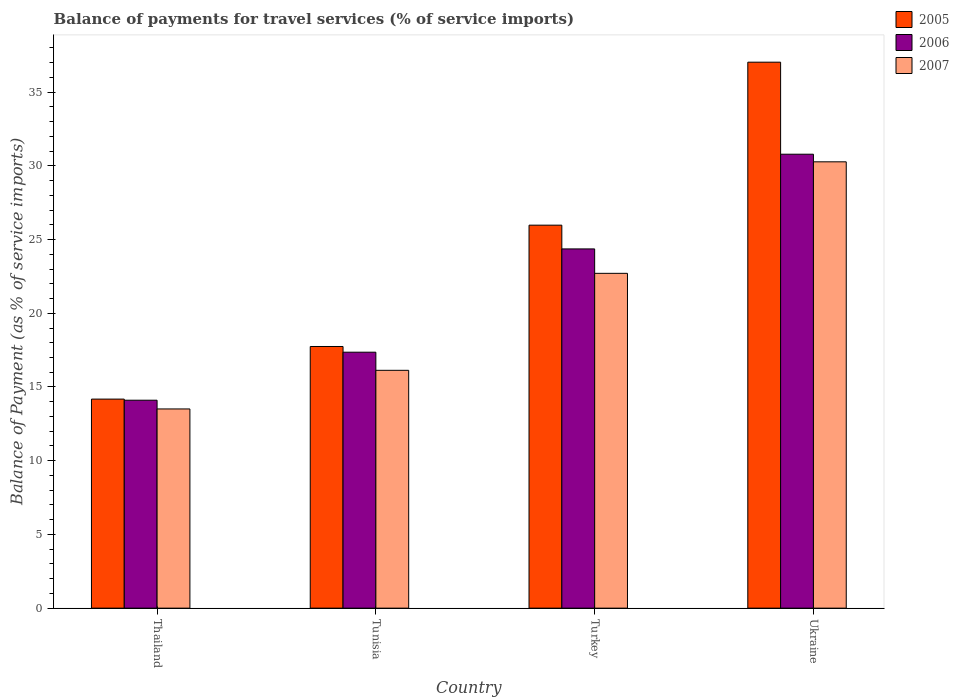How many different coloured bars are there?
Offer a very short reply. 3. Are the number of bars per tick equal to the number of legend labels?
Your answer should be very brief. Yes. Are the number of bars on each tick of the X-axis equal?
Give a very brief answer. Yes. How many bars are there on the 1st tick from the left?
Make the answer very short. 3. What is the label of the 2nd group of bars from the left?
Offer a terse response. Tunisia. In how many cases, is the number of bars for a given country not equal to the number of legend labels?
Your answer should be very brief. 0. What is the balance of payments for travel services in 2006 in Tunisia?
Provide a short and direct response. 17.36. Across all countries, what is the maximum balance of payments for travel services in 2006?
Your answer should be compact. 30.79. Across all countries, what is the minimum balance of payments for travel services in 2007?
Provide a succinct answer. 13.51. In which country was the balance of payments for travel services in 2005 maximum?
Offer a terse response. Ukraine. In which country was the balance of payments for travel services in 2005 minimum?
Offer a terse response. Thailand. What is the total balance of payments for travel services in 2006 in the graph?
Keep it short and to the point. 86.61. What is the difference between the balance of payments for travel services in 2007 in Tunisia and that in Ukraine?
Provide a succinct answer. -14.14. What is the difference between the balance of payments for travel services in 2007 in Ukraine and the balance of payments for travel services in 2006 in Tunisia?
Your answer should be compact. 12.91. What is the average balance of payments for travel services in 2007 per country?
Make the answer very short. 20.65. What is the difference between the balance of payments for travel services of/in 2005 and balance of payments for travel services of/in 2007 in Thailand?
Give a very brief answer. 0.67. What is the ratio of the balance of payments for travel services in 2007 in Thailand to that in Ukraine?
Your answer should be compact. 0.45. Is the balance of payments for travel services in 2007 in Thailand less than that in Tunisia?
Keep it short and to the point. Yes. Is the difference between the balance of payments for travel services in 2005 in Tunisia and Ukraine greater than the difference between the balance of payments for travel services in 2007 in Tunisia and Ukraine?
Offer a terse response. No. What is the difference between the highest and the second highest balance of payments for travel services in 2006?
Your answer should be very brief. 7.01. What is the difference between the highest and the lowest balance of payments for travel services in 2007?
Offer a very short reply. 16.76. Is the sum of the balance of payments for travel services in 2005 in Tunisia and Ukraine greater than the maximum balance of payments for travel services in 2006 across all countries?
Make the answer very short. Yes. What does the 1st bar from the right in Turkey represents?
Offer a terse response. 2007. Is it the case that in every country, the sum of the balance of payments for travel services in 2005 and balance of payments for travel services in 2007 is greater than the balance of payments for travel services in 2006?
Your answer should be very brief. Yes. Does the graph contain any zero values?
Your answer should be compact. No. Does the graph contain grids?
Provide a succinct answer. No. How many legend labels are there?
Provide a short and direct response. 3. What is the title of the graph?
Offer a very short reply. Balance of payments for travel services (% of service imports). Does "1983" appear as one of the legend labels in the graph?
Ensure brevity in your answer.  No. What is the label or title of the X-axis?
Provide a succinct answer. Country. What is the label or title of the Y-axis?
Make the answer very short. Balance of Payment (as % of service imports). What is the Balance of Payment (as % of service imports) in 2005 in Thailand?
Your response must be concise. 14.18. What is the Balance of Payment (as % of service imports) in 2006 in Thailand?
Give a very brief answer. 14.1. What is the Balance of Payment (as % of service imports) in 2007 in Thailand?
Offer a very short reply. 13.51. What is the Balance of Payment (as % of service imports) in 2005 in Tunisia?
Provide a short and direct response. 17.75. What is the Balance of Payment (as % of service imports) in 2006 in Tunisia?
Your response must be concise. 17.36. What is the Balance of Payment (as % of service imports) of 2007 in Tunisia?
Your answer should be compact. 16.13. What is the Balance of Payment (as % of service imports) in 2005 in Turkey?
Make the answer very short. 25.97. What is the Balance of Payment (as % of service imports) in 2006 in Turkey?
Your answer should be very brief. 24.36. What is the Balance of Payment (as % of service imports) in 2007 in Turkey?
Your answer should be compact. 22.71. What is the Balance of Payment (as % of service imports) of 2005 in Ukraine?
Your answer should be very brief. 37.03. What is the Balance of Payment (as % of service imports) of 2006 in Ukraine?
Keep it short and to the point. 30.79. What is the Balance of Payment (as % of service imports) in 2007 in Ukraine?
Your answer should be very brief. 30.27. Across all countries, what is the maximum Balance of Payment (as % of service imports) in 2005?
Provide a short and direct response. 37.03. Across all countries, what is the maximum Balance of Payment (as % of service imports) of 2006?
Keep it short and to the point. 30.79. Across all countries, what is the maximum Balance of Payment (as % of service imports) in 2007?
Keep it short and to the point. 30.27. Across all countries, what is the minimum Balance of Payment (as % of service imports) of 2005?
Ensure brevity in your answer.  14.18. Across all countries, what is the minimum Balance of Payment (as % of service imports) in 2006?
Ensure brevity in your answer.  14.1. Across all countries, what is the minimum Balance of Payment (as % of service imports) of 2007?
Your answer should be compact. 13.51. What is the total Balance of Payment (as % of service imports) of 2005 in the graph?
Keep it short and to the point. 94.93. What is the total Balance of Payment (as % of service imports) in 2006 in the graph?
Your response must be concise. 86.61. What is the total Balance of Payment (as % of service imports) in 2007 in the graph?
Keep it short and to the point. 82.62. What is the difference between the Balance of Payment (as % of service imports) in 2005 in Thailand and that in Tunisia?
Keep it short and to the point. -3.57. What is the difference between the Balance of Payment (as % of service imports) in 2006 in Thailand and that in Tunisia?
Your answer should be compact. -3.26. What is the difference between the Balance of Payment (as % of service imports) of 2007 in Thailand and that in Tunisia?
Your answer should be compact. -2.62. What is the difference between the Balance of Payment (as % of service imports) in 2005 in Thailand and that in Turkey?
Your answer should be very brief. -11.8. What is the difference between the Balance of Payment (as % of service imports) in 2006 in Thailand and that in Turkey?
Provide a succinct answer. -10.26. What is the difference between the Balance of Payment (as % of service imports) of 2007 in Thailand and that in Turkey?
Keep it short and to the point. -9.2. What is the difference between the Balance of Payment (as % of service imports) in 2005 in Thailand and that in Ukraine?
Provide a succinct answer. -22.85. What is the difference between the Balance of Payment (as % of service imports) in 2006 in Thailand and that in Ukraine?
Make the answer very short. -16.68. What is the difference between the Balance of Payment (as % of service imports) of 2007 in Thailand and that in Ukraine?
Keep it short and to the point. -16.76. What is the difference between the Balance of Payment (as % of service imports) of 2005 in Tunisia and that in Turkey?
Your answer should be compact. -8.23. What is the difference between the Balance of Payment (as % of service imports) in 2006 in Tunisia and that in Turkey?
Provide a succinct answer. -7.01. What is the difference between the Balance of Payment (as % of service imports) in 2007 in Tunisia and that in Turkey?
Provide a short and direct response. -6.58. What is the difference between the Balance of Payment (as % of service imports) of 2005 in Tunisia and that in Ukraine?
Ensure brevity in your answer.  -19.28. What is the difference between the Balance of Payment (as % of service imports) in 2006 in Tunisia and that in Ukraine?
Give a very brief answer. -13.43. What is the difference between the Balance of Payment (as % of service imports) of 2007 in Tunisia and that in Ukraine?
Ensure brevity in your answer.  -14.14. What is the difference between the Balance of Payment (as % of service imports) of 2005 in Turkey and that in Ukraine?
Make the answer very short. -11.05. What is the difference between the Balance of Payment (as % of service imports) of 2006 in Turkey and that in Ukraine?
Keep it short and to the point. -6.42. What is the difference between the Balance of Payment (as % of service imports) of 2007 in Turkey and that in Ukraine?
Your answer should be very brief. -7.56. What is the difference between the Balance of Payment (as % of service imports) in 2005 in Thailand and the Balance of Payment (as % of service imports) in 2006 in Tunisia?
Offer a terse response. -3.18. What is the difference between the Balance of Payment (as % of service imports) of 2005 in Thailand and the Balance of Payment (as % of service imports) of 2007 in Tunisia?
Your answer should be very brief. -1.95. What is the difference between the Balance of Payment (as % of service imports) in 2006 in Thailand and the Balance of Payment (as % of service imports) in 2007 in Tunisia?
Ensure brevity in your answer.  -2.03. What is the difference between the Balance of Payment (as % of service imports) of 2005 in Thailand and the Balance of Payment (as % of service imports) of 2006 in Turkey?
Give a very brief answer. -10.19. What is the difference between the Balance of Payment (as % of service imports) of 2005 in Thailand and the Balance of Payment (as % of service imports) of 2007 in Turkey?
Ensure brevity in your answer.  -8.53. What is the difference between the Balance of Payment (as % of service imports) in 2006 in Thailand and the Balance of Payment (as % of service imports) in 2007 in Turkey?
Give a very brief answer. -8.61. What is the difference between the Balance of Payment (as % of service imports) in 2005 in Thailand and the Balance of Payment (as % of service imports) in 2006 in Ukraine?
Offer a terse response. -16.61. What is the difference between the Balance of Payment (as % of service imports) of 2005 in Thailand and the Balance of Payment (as % of service imports) of 2007 in Ukraine?
Offer a very short reply. -16.09. What is the difference between the Balance of Payment (as % of service imports) of 2006 in Thailand and the Balance of Payment (as % of service imports) of 2007 in Ukraine?
Provide a succinct answer. -16.17. What is the difference between the Balance of Payment (as % of service imports) in 2005 in Tunisia and the Balance of Payment (as % of service imports) in 2006 in Turkey?
Provide a succinct answer. -6.62. What is the difference between the Balance of Payment (as % of service imports) in 2005 in Tunisia and the Balance of Payment (as % of service imports) in 2007 in Turkey?
Your response must be concise. -4.96. What is the difference between the Balance of Payment (as % of service imports) of 2006 in Tunisia and the Balance of Payment (as % of service imports) of 2007 in Turkey?
Make the answer very short. -5.35. What is the difference between the Balance of Payment (as % of service imports) of 2005 in Tunisia and the Balance of Payment (as % of service imports) of 2006 in Ukraine?
Make the answer very short. -13.04. What is the difference between the Balance of Payment (as % of service imports) in 2005 in Tunisia and the Balance of Payment (as % of service imports) in 2007 in Ukraine?
Provide a succinct answer. -12.53. What is the difference between the Balance of Payment (as % of service imports) of 2006 in Tunisia and the Balance of Payment (as % of service imports) of 2007 in Ukraine?
Your response must be concise. -12.91. What is the difference between the Balance of Payment (as % of service imports) in 2005 in Turkey and the Balance of Payment (as % of service imports) in 2006 in Ukraine?
Provide a succinct answer. -4.81. What is the difference between the Balance of Payment (as % of service imports) of 2005 in Turkey and the Balance of Payment (as % of service imports) of 2007 in Ukraine?
Provide a succinct answer. -4.3. What is the difference between the Balance of Payment (as % of service imports) of 2006 in Turkey and the Balance of Payment (as % of service imports) of 2007 in Ukraine?
Give a very brief answer. -5.91. What is the average Balance of Payment (as % of service imports) in 2005 per country?
Keep it short and to the point. 23.73. What is the average Balance of Payment (as % of service imports) of 2006 per country?
Make the answer very short. 21.65. What is the average Balance of Payment (as % of service imports) of 2007 per country?
Give a very brief answer. 20.66. What is the difference between the Balance of Payment (as % of service imports) in 2005 and Balance of Payment (as % of service imports) in 2006 in Thailand?
Keep it short and to the point. 0.08. What is the difference between the Balance of Payment (as % of service imports) in 2005 and Balance of Payment (as % of service imports) in 2007 in Thailand?
Your response must be concise. 0.67. What is the difference between the Balance of Payment (as % of service imports) of 2006 and Balance of Payment (as % of service imports) of 2007 in Thailand?
Provide a short and direct response. 0.59. What is the difference between the Balance of Payment (as % of service imports) of 2005 and Balance of Payment (as % of service imports) of 2006 in Tunisia?
Your response must be concise. 0.39. What is the difference between the Balance of Payment (as % of service imports) in 2005 and Balance of Payment (as % of service imports) in 2007 in Tunisia?
Keep it short and to the point. 1.62. What is the difference between the Balance of Payment (as % of service imports) of 2006 and Balance of Payment (as % of service imports) of 2007 in Tunisia?
Your answer should be compact. 1.23. What is the difference between the Balance of Payment (as % of service imports) in 2005 and Balance of Payment (as % of service imports) in 2006 in Turkey?
Give a very brief answer. 1.61. What is the difference between the Balance of Payment (as % of service imports) in 2005 and Balance of Payment (as % of service imports) in 2007 in Turkey?
Your answer should be very brief. 3.27. What is the difference between the Balance of Payment (as % of service imports) in 2006 and Balance of Payment (as % of service imports) in 2007 in Turkey?
Ensure brevity in your answer.  1.66. What is the difference between the Balance of Payment (as % of service imports) of 2005 and Balance of Payment (as % of service imports) of 2006 in Ukraine?
Your answer should be compact. 6.24. What is the difference between the Balance of Payment (as % of service imports) of 2005 and Balance of Payment (as % of service imports) of 2007 in Ukraine?
Provide a short and direct response. 6.76. What is the difference between the Balance of Payment (as % of service imports) of 2006 and Balance of Payment (as % of service imports) of 2007 in Ukraine?
Ensure brevity in your answer.  0.52. What is the ratio of the Balance of Payment (as % of service imports) of 2005 in Thailand to that in Tunisia?
Offer a very short reply. 0.8. What is the ratio of the Balance of Payment (as % of service imports) in 2006 in Thailand to that in Tunisia?
Keep it short and to the point. 0.81. What is the ratio of the Balance of Payment (as % of service imports) in 2007 in Thailand to that in Tunisia?
Give a very brief answer. 0.84. What is the ratio of the Balance of Payment (as % of service imports) in 2005 in Thailand to that in Turkey?
Ensure brevity in your answer.  0.55. What is the ratio of the Balance of Payment (as % of service imports) in 2006 in Thailand to that in Turkey?
Ensure brevity in your answer.  0.58. What is the ratio of the Balance of Payment (as % of service imports) in 2007 in Thailand to that in Turkey?
Your answer should be compact. 0.59. What is the ratio of the Balance of Payment (as % of service imports) of 2005 in Thailand to that in Ukraine?
Provide a succinct answer. 0.38. What is the ratio of the Balance of Payment (as % of service imports) of 2006 in Thailand to that in Ukraine?
Provide a succinct answer. 0.46. What is the ratio of the Balance of Payment (as % of service imports) in 2007 in Thailand to that in Ukraine?
Offer a terse response. 0.45. What is the ratio of the Balance of Payment (as % of service imports) of 2005 in Tunisia to that in Turkey?
Provide a short and direct response. 0.68. What is the ratio of the Balance of Payment (as % of service imports) of 2006 in Tunisia to that in Turkey?
Ensure brevity in your answer.  0.71. What is the ratio of the Balance of Payment (as % of service imports) of 2007 in Tunisia to that in Turkey?
Your answer should be compact. 0.71. What is the ratio of the Balance of Payment (as % of service imports) of 2005 in Tunisia to that in Ukraine?
Offer a terse response. 0.48. What is the ratio of the Balance of Payment (as % of service imports) of 2006 in Tunisia to that in Ukraine?
Keep it short and to the point. 0.56. What is the ratio of the Balance of Payment (as % of service imports) of 2007 in Tunisia to that in Ukraine?
Provide a short and direct response. 0.53. What is the ratio of the Balance of Payment (as % of service imports) of 2005 in Turkey to that in Ukraine?
Give a very brief answer. 0.7. What is the ratio of the Balance of Payment (as % of service imports) of 2006 in Turkey to that in Ukraine?
Keep it short and to the point. 0.79. What is the ratio of the Balance of Payment (as % of service imports) of 2007 in Turkey to that in Ukraine?
Ensure brevity in your answer.  0.75. What is the difference between the highest and the second highest Balance of Payment (as % of service imports) in 2005?
Ensure brevity in your answer.  11.05. What is the difference between the highest and the second highest Balance of Payment (as % of service imports) in 2006?
Your answer should be compact. 6.42. What is the difference between the highest and the second highest Balance of Payment (as % of service imports) in 2007?
Offer a terse response. 7.56. What is the difference between the highest and the lowest Balance of Payment (as % of service imports) of 2005?
Offer a very short reply. 22.85. What is the difference between the highest and the lowest Balance of Payment (as % of service imports) of 2006?
Ensure brevity in your answer.  16.68. What is the difference between the highest and the lowest Balance of Payment (as % of service imports) of 2007?
Your answer should be compact. 16.76. 